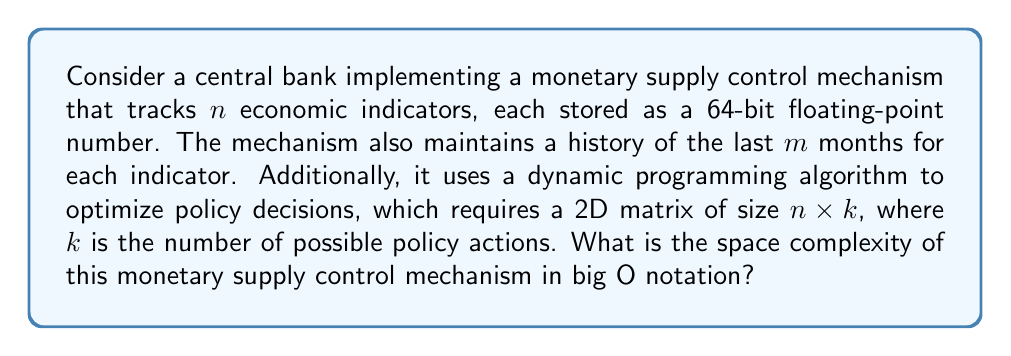Teach me how to tackle this problem. To determine the space complexity, let's break down the components of the monetary supply control mechanism:

1. Economic indicators:
   - $n$ indicators
   - Each indicator is a 64-bit float
   - Space required: $O(n)$

2. Historical data:
   - $n$ indicators
   - $m$ months of history for each indicator
   - Space required: $O(n \cdot m)$

3. Dynamic programming matrix:
   - Size: $n \times k$
   - Space required: $O(n \cdot k)$

The total space complexity is the sum of these components:

$$O(n) + O(n \cdot m) + O(n \cdot k)$$

Since we're using big O notation, we can simplify this by considering the dominant terms. The term with the largest growth rate will be either $O(n \cdot m)$ or $O(n \cdot k)$, depending on which is larger between $m$ and $k$.

We can express this as:

$$O(n \cdot \max(m, k))$$

This represents the upper bound on the space complexity of the monetary supply control mechanism.
Answer: $O(n \cdot \max(m, k))$ 